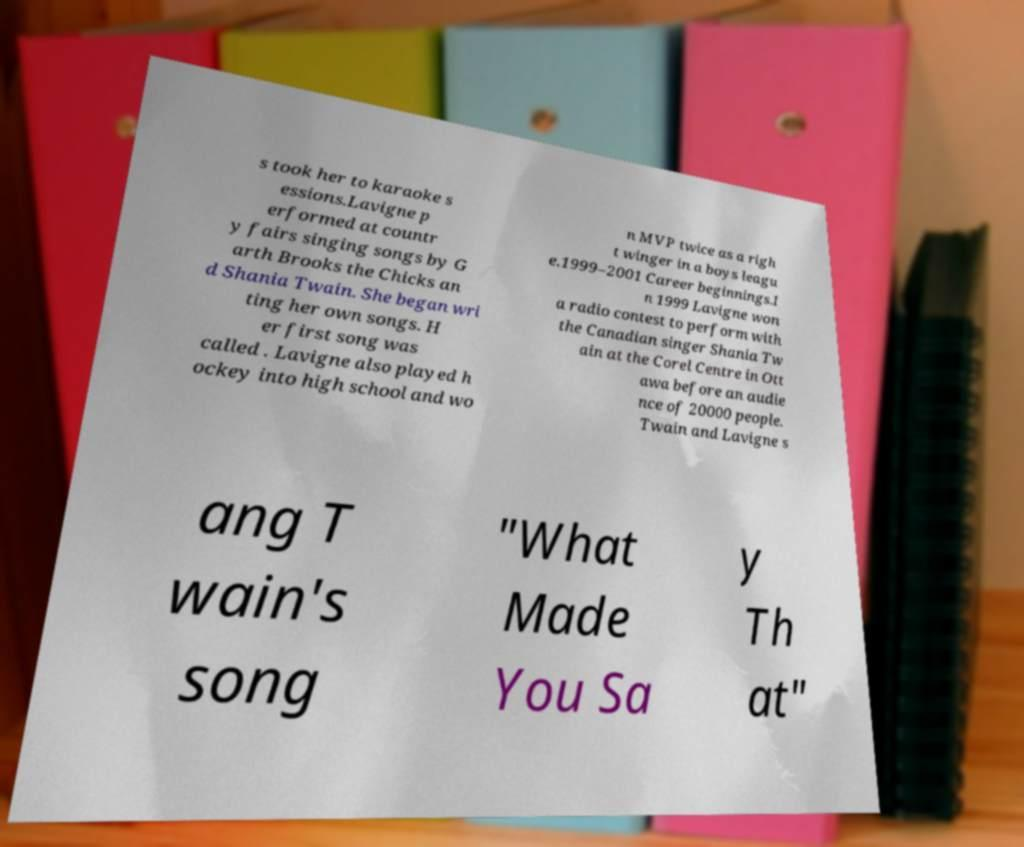Please identify and transcribe the text found in this image. s took her to karaoke s essions.Lavigne p erformed at countr y fairs singing songs by G arth Brooks the Chicks an d Shania Twain. She began wri ting her own songs. H er first song was called . Lavigne also played h ockey into high school and wo n MVP twice as a righ t winger in a boys leagu e.1999–2001 Career beginnings.I n 1999 Lavigne won a radio contest to perform with the Canadian singer Shania Tw ain at the Corel Centre in Ott awa before an audie nce of 20000 people. Twain and Lavigne s ang T wain's song "What Made You Sa y Th at" 